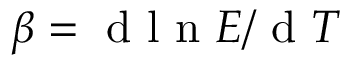Convert formula to latex. <formula><loc_0><loc_0><loc_500><loc_500>\beta = d l n E / d T</formula> 